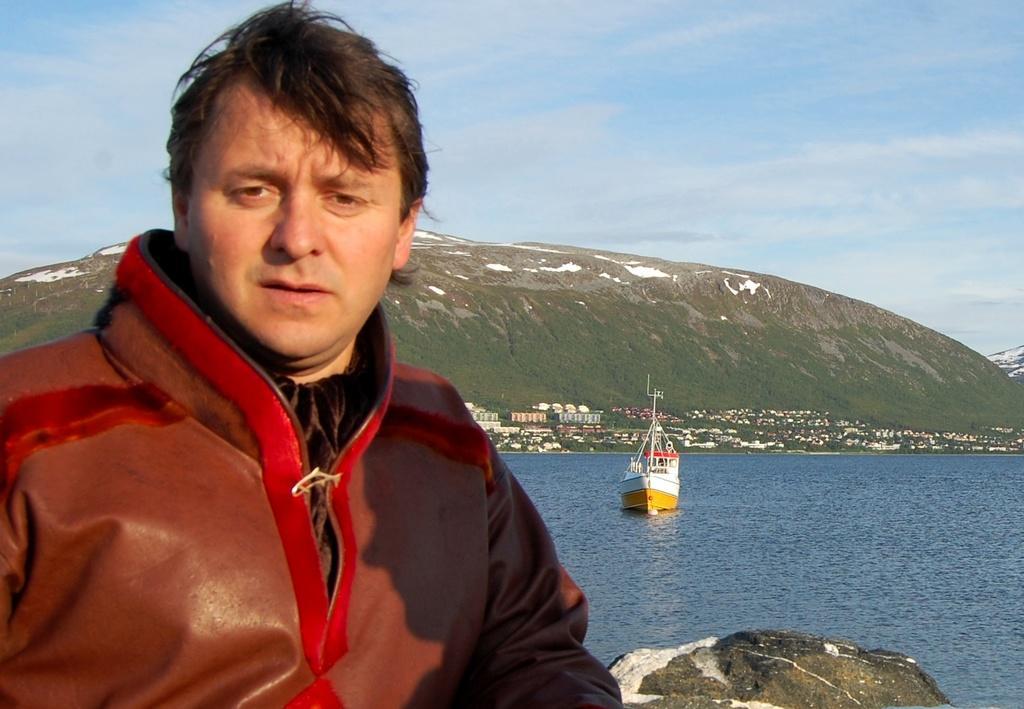Can you describe this image briefly? In this picture we can see a man and at the back of him we can see a boat on the water, rock, buildings, grass, mountain and in the background we can see the sky with clouds. 